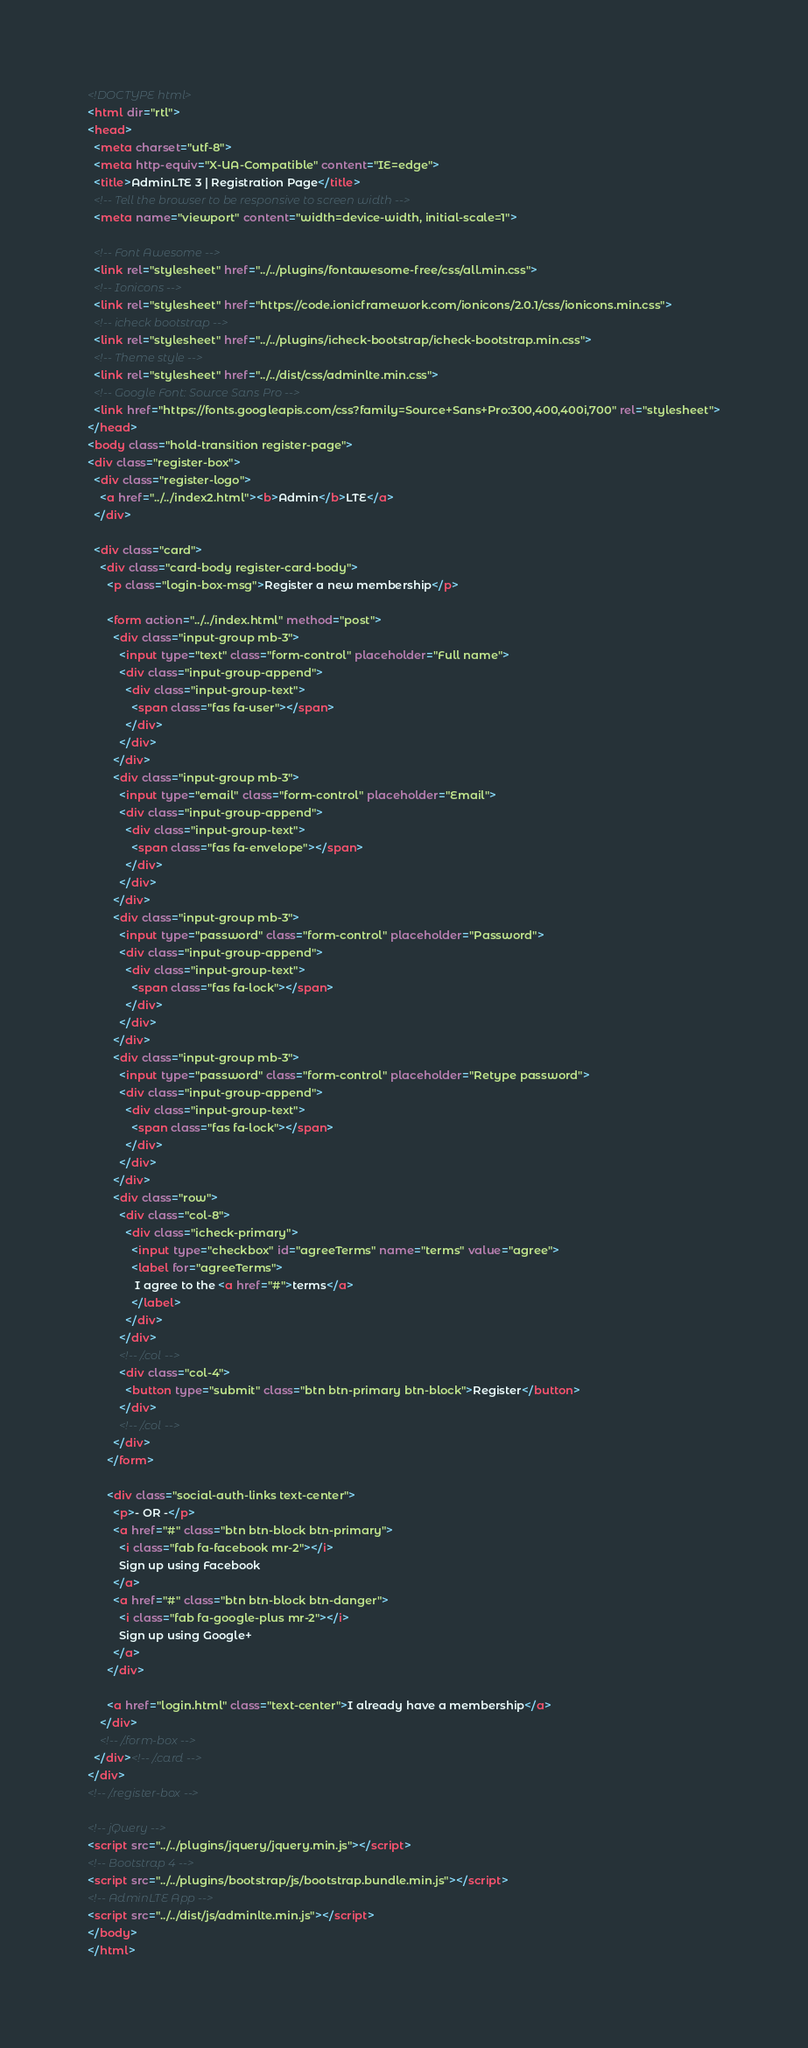Convert code to text. <code><loc_0><loc_0><loc_500><loc_500><_HTML_><!DOCTYPE html>
<html dir="rtl">
<head>
  <meta charset="utf-8">
  <meta http-equiv="X-UA-Compatible" content="IE=edge">
  <title>AdminLTE 3 | Registration Page</title>
  <!-- Tell the browser to be responsive to screen width -->
  <meta name="viewport" content="width=device-width, initial-scale=1">

  <!-- Font Awesome -->
  <link rel="stylesheet" href="../../plugins/fontawesome-free/css/all.min.css">
  <!-- Ionicons -->
  <link rel="stylesheet" href="https://code.ionicframework.com/ionicons/2.0.1/css/ionicons.min.css">
  <!-- icheck bootstrap -->
  <link rel="stylesheet" href="../../plugins/icheck-bootstrap/icheck-bootstrap.min.css">
  <!-- Theme style -->
  <link rel="stylesheet" href="../../dist/css/adminlte.min.css">
  <!-- Google Font: Source Sans Pro -->
  <link href="https://fonts.googleapis.com/css?family=Source+Sans+Pro:300,400,400i,700" rel="stylesheet">
</head>
<body class="hold-transition register-page">
<div class="register-box">
  <div class="register-logo">
    <a href="../../index2.html"><b>Admin</b>LTE</a>
  </div>

  <div class="card">
    <div class="card-body register-card-body">
      <p class="login-box-msg">Register a new membership</p>

      <form action="../../index.html" method="post">
        <div class="input-group mb-3">
          <input type="text" class="form-control" placeholder="Full name">
          <div class="input-group-append">
            <div class="input-group-text">
              <span class="fas fa-user"></span>
            </div>
          </div>
        </div>
        <div class="input-group mb-3">
          <input type="email" class="form-control" placeholder="Email">
          <div class="input-group-append">
            <div class="input-group-text">
              <span class="fas fa-envelope"></span>
            </div>
          </div>
        </div>
        <div class="input-group mb-3">
          <input type="password" class="form-control" placeholder="Password">
          <div class="input-group-append">
            <div class="input-group-text">
              <span class="fas fa-lock"></span>
            </div>
          </div>
        </div>
        <div class="input-group mb-3">
          <input type="password" class="form-control" placeholder="Retype password">
          <div class="input-group-append">
            <div class="input-group-text">
              <span class="fas fa-lock"></span>
            </div>
          </div>
        </div>
        <div class="row">
          <div class="col-8">
            <div class="icheck-primary">
              <input type="checkbox" id="agreeTerms" name="terms" value="agree">
              <label for="agreeTerms">
               I agree to the <a href="#">terms</a>
              </label>
            </div>
          </div>
          <!-- /.col -->
          <div class="col-4">
            <button type="submit" class="btn btn-primary btn-block">Register</button>
          </div>
          <!-- /.col -->
        </div>
      </form>

      <div class="social-auth-links text-center">
        <p>- OR -</p>
        <a href="#" class="btn btn-block btn-primary">
          <i class="fab fa-facebook mr-2"></i>
          Sign up using Facebook
        </a>
        <a href="#" class="btn btn-block btn-danger">
          <i class="fab fa-google-plus mr-2"></i>
          Sign up using Google+
        </a>
      </div>

      <a href="login.html" class="text-center">I already have a membership</a>
    </div>
    <!-- /.form-box -->
  </div><!-- /.card -->
</div>
<!-- /.register-box -->

<!-- jQuery -->
<script src="../../plugins/jquery/jquery.min.js"></script>
<!-- Bootstrap 4 -->
<script src="../../plugins/bootstrap/js/bootstrap.bundle.min.js"></script>
<!-- AdminLTE App -->
<script src="../../dist/js/adminlte.min.js"></script>
</body>
</html>
</code> 